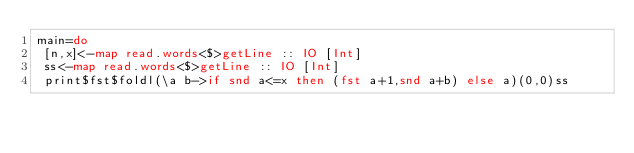<code> <loc_0><loc_0><loc_500><loc_500><_Haskell_>main=do
 [n,x]<-map read.words<$>getLine :: IO [Int]
 ss<-map read.words<$>getLine :: IO [Int]
 print$fst$foldl(\a b->if snd a<=x then (fst a+1,snd a+b) else a)(0,0)ss</code> 